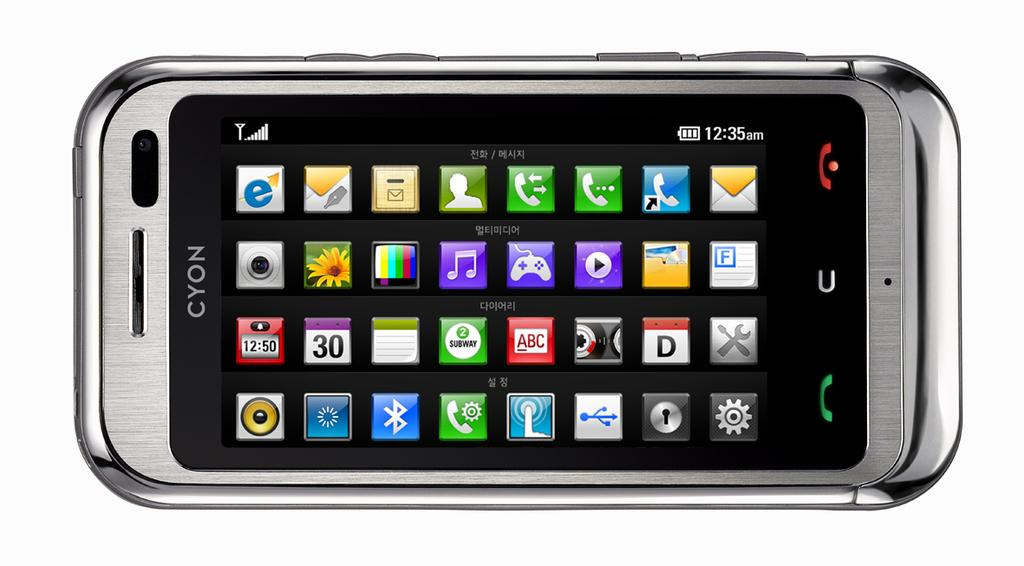<image>
Write a terse but informative summary of the picture. The screen of a cyon branded  cell phone with several icons for apps on the screen. 